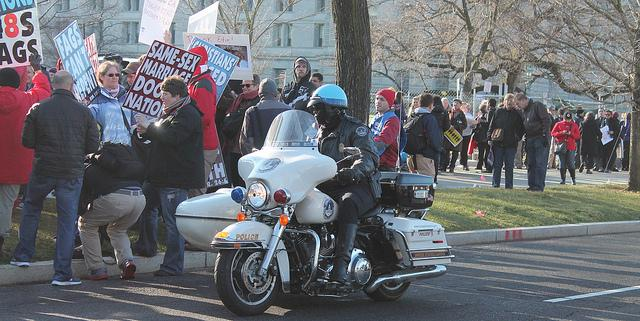What sort of sex is everyone here thinking about? Please explain your reasoning. gay. The people have signs about same sex marriage. 